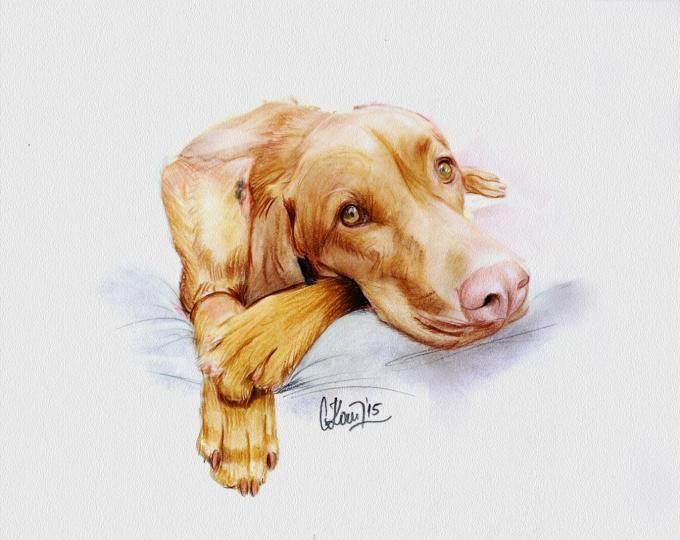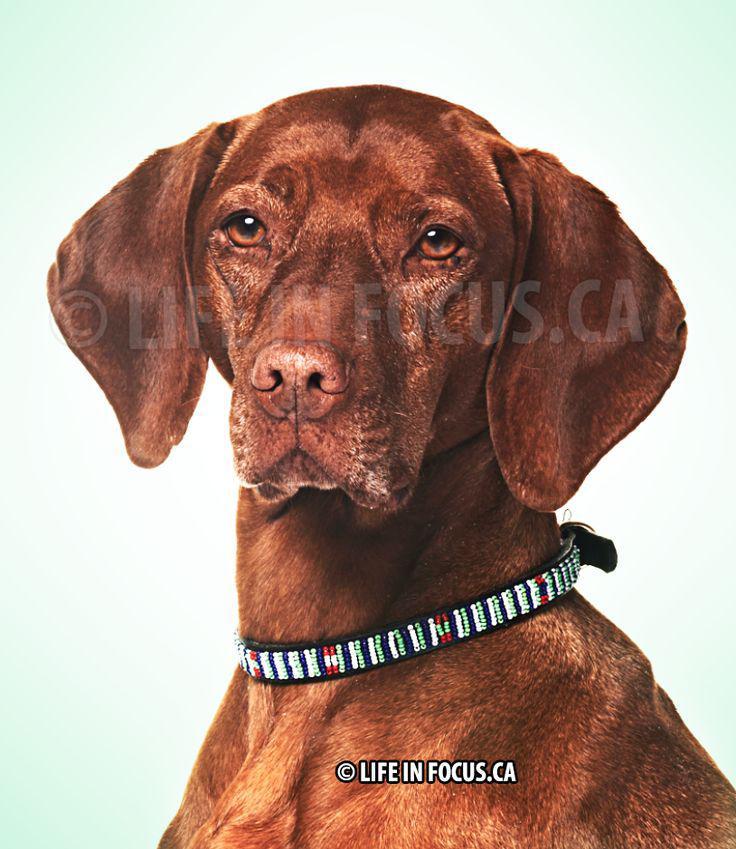The first image is the image on the left, the second image is the image on the right. Examine the images to the left and right. Is the description "In at least one image, there is a redbone coonhound sitting with his head facing left." accurate? Answer yes or no. No. The first image is the image on the left, the second image is the image on the right. For the images shown, is this caption "The right image contains a red-orange dog with an upright head gazing straight ahead, and the left image contains a dog with its muzzle pointing rightward." true? Answer yes or no. Yes. 